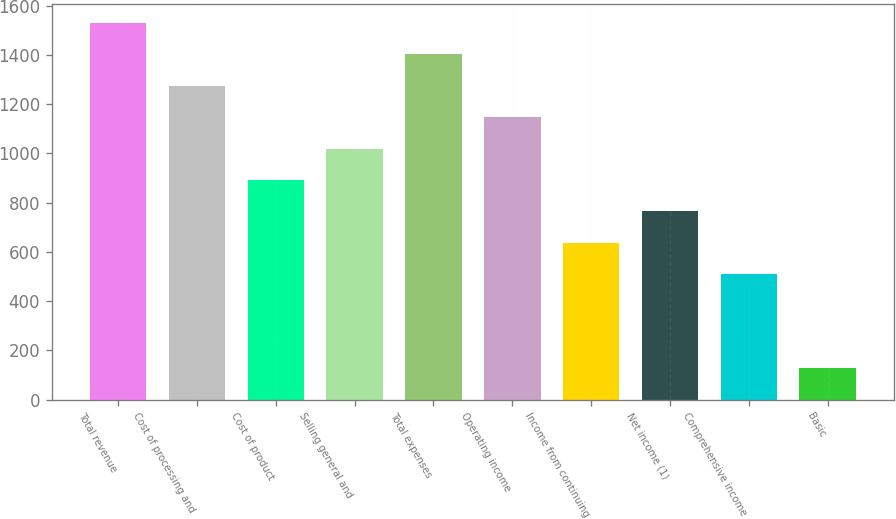Convert chart to OTSL. <chart><loc_0><loc_0><loc_500><loc_500><bar_chart><fcel>Total revenue<fcel>Cost of processing and<fcel>Cost of product<fcel>Selling general and<fcel>Total expenses<fcel>Operating income<fcel>Income from continuing<fcel>Net income (1)<fcel>Comprehensive income<fcel>Basic<nl><fcel>1529.89<fcel>1275.03<fcel>892.74<fcel>1020.17<fcel>1402.46<fcel>1147.6<fcel>637.88<fcel>765.31<fcel>510.45<fcel>128.16<nl></chart> 